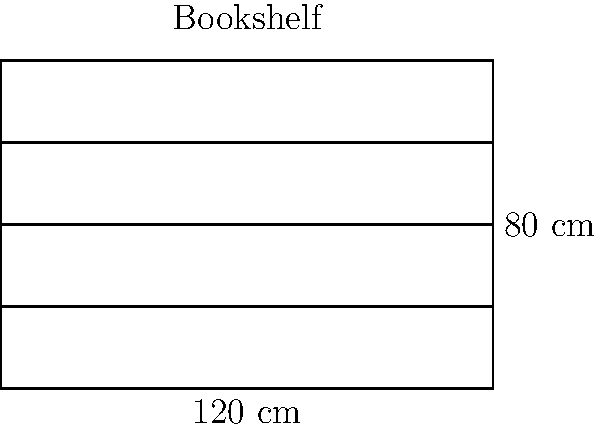As you prepare to build a new bookshelf for your grandchildren's story time corner, you decide to calculate its perimeter. The bookshelf has a width of 120 cm and a height of 80 cm, as shown in the diagram. What is the perimeter of this rectangular bookshelf in centimeters? To calculate the perimeter of the rectangular bookshelf, we need to follow these steps:

1. Recall the formula for the perimeter of a rectangle:
   $$P = 2l + 2w$$
   where $P$ is the perimeter, $l$ is the length (height in this case), and $w$ is the width.

2. Identify the given dimensions:
   Height (length) = 80 cm
   Width = 120 cm

3. Substitute these values into the formula:
   $$P = 2(80) + 2(120)$$

4. Simplify:
   $$P = 160 + 240$$

5. Calculate the final result:
   $$P = 400$$

Therefore, the perimeter of the bookshelf is 400 cm.
Answer: 400 cm 